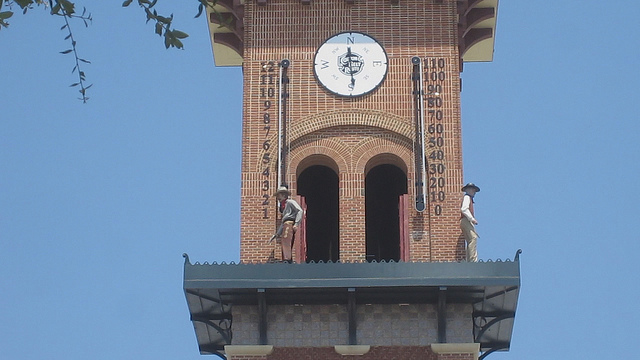What is the device shown in the image?
A. painting
B. clock
C. photography
D. compass
Answer with the option's letter from the given choices directly. The device shown in the image is a clock, which can be identified by its circular face, marked with numbers and two moving hands that indicate the time. It's a large public clock, often found in towers or at central locations in towns and cities to allow the public to see the time from a distance. The presence of this clock on what appears to be a tower adds to the architectural beauty and historical value of the structure, serving both a practical and an aesthetic function in its setting. 